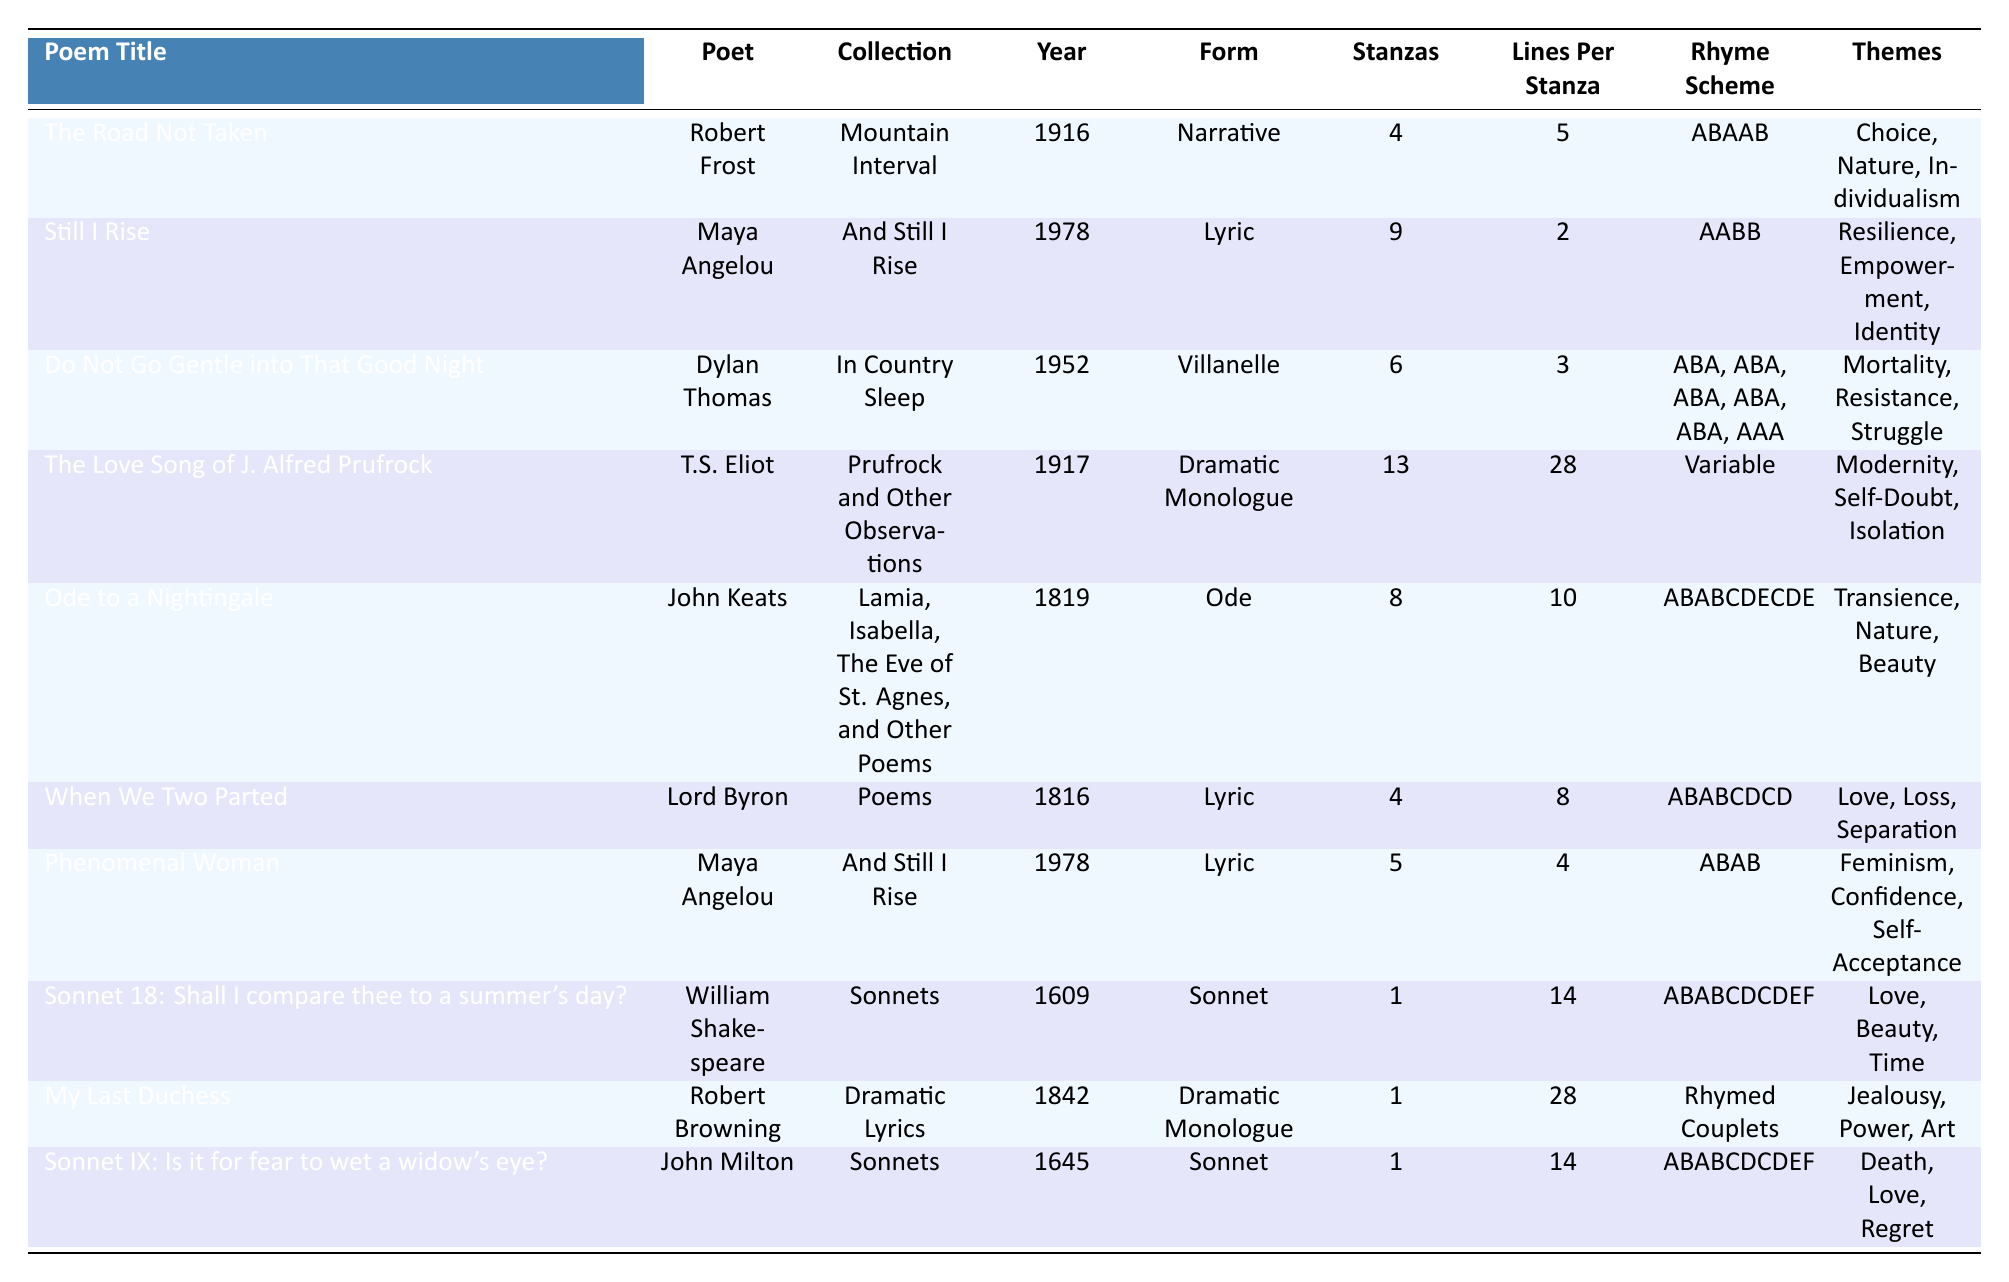What is the rhyme scheme of "Ode to a Nightingale"? The table lists "Ode to a Nightingale" under the Rhyme Scheme column. The specific rhyme scheme for this poem is ABABCDECDE.
Answer: ABABCDECDE Who is the poet of "Do Not Go Gentle into That Good Night"? The table provides the author name next to the poem title "Do Not Go Gentle into That Good Night." The poet is Dylan Thomas.
Answer: Dylan Thomas Which poem was published first, "Sonnet IX" or "When We Two Parted"? To determine the first publication date, we compare the years listed in the Year column for both poems. "Sonnet IX" was published in 1645 and "When We Two Parted" in 1816, so "Sonnet IX" was published first.
Answer: Sonnet IX How many stanzas are in "Still I Rise"? The table lists "Still I Rise" with a value of 9 in the Stanzas column, indicating it contains 9 stanzas.
Answer: 9 Which form is most represented in this collection of poems? To find the most represented form, we count the occurrences of each form in the Form column. "Lyric" appears three times, while "Dramatic Monologue," "Sonnet," and other forms appear less frequently. Therefore, "Lyric" is the most represented form.
Answer: Lyric What are the themes associated with "The Love Song of J. Alfred Prufrock"? The themes for "The Love Song of J. Alfred Prufrock" are listed in the Themes column. They are Modernity, Self-Doubt, and Isolation.
Answer: Modernity, Self-Doubt, Isolation What is the average number of lines per stanza across all poems? To calculate the average, sum all the values in the Lines Per Stanza column and divide by the number of poems. The total lines from the column are 5 + 2 + 3 + 28 + 10 + 8 + 4 + 14 + 28 + 14 = 114. There are 10 poems, so the average is 114 / 10 = 11.4.
Answer: 11.4 Is "Phenomenal Woman" a sonnet? Checking the Form column for "Phenomenal Woman," it is categorized as "Lyric," not a sonnet.
Answer: No Which poem has the longest lines per stanza? In the Lines Per Stanza column, we look for the highest number. "The Love Song of J. Alfred Prufrock" has 28 lines per stanza, which is the highest.
Answer: The Love Song of J. Alfred Prufrock What is the total number of stanzas across all poems? To find the total, we sum the values in the Stanzas column: 4 + 9 + 6 + 13 + 8 + 4 + 5 + 1 + 1 + 1 = 52.
Answer: 52 